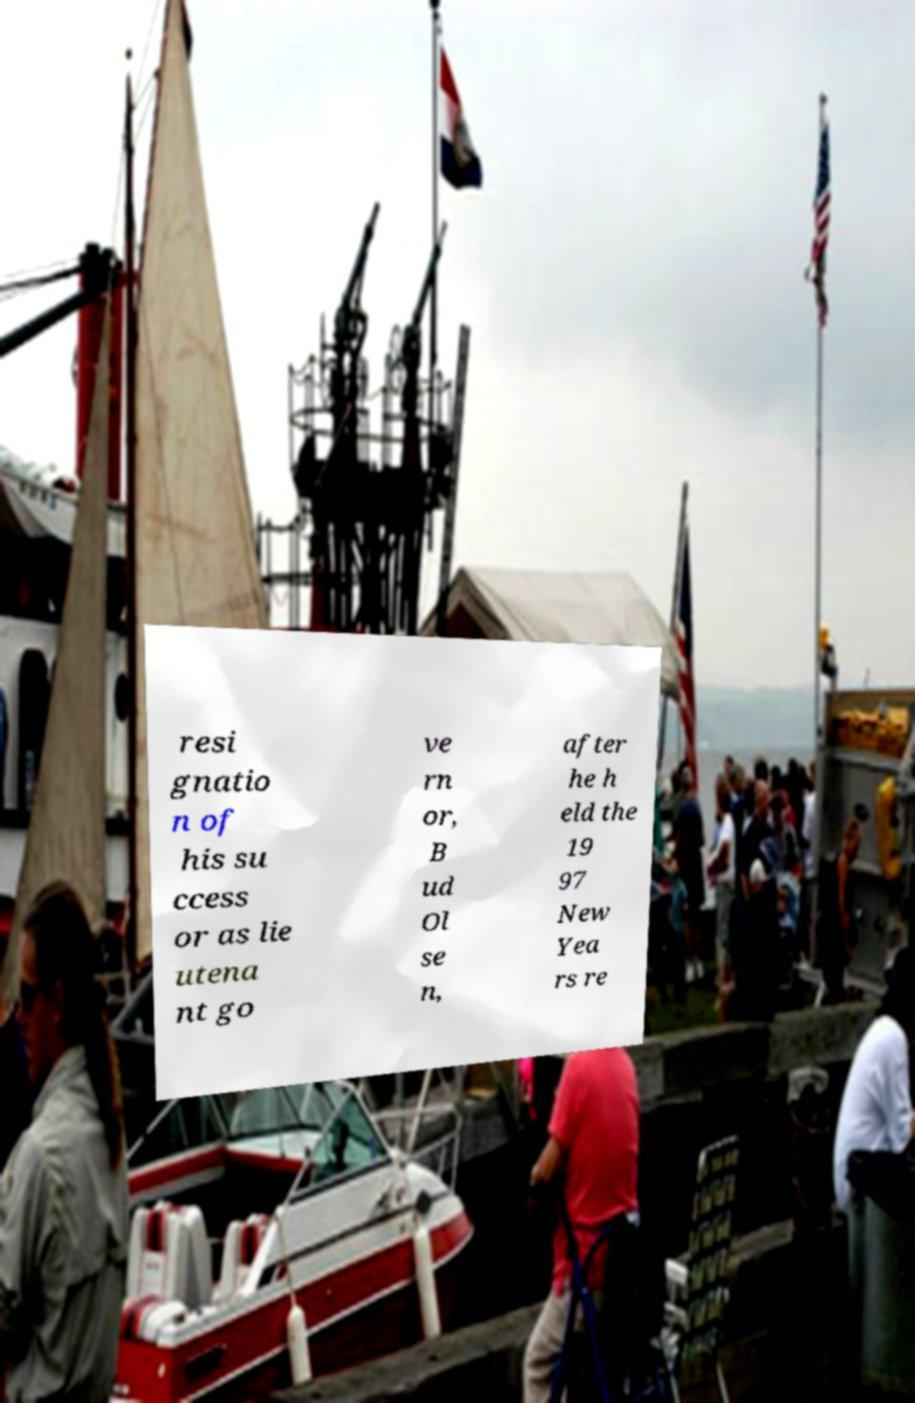Can you accurately transcribe the text from the provided image for me? resi gnatio n of his su ccess or as lie utena nt go ve rn or, B ud Ol se n, after he h eld the 19 97 New Yea rs re 